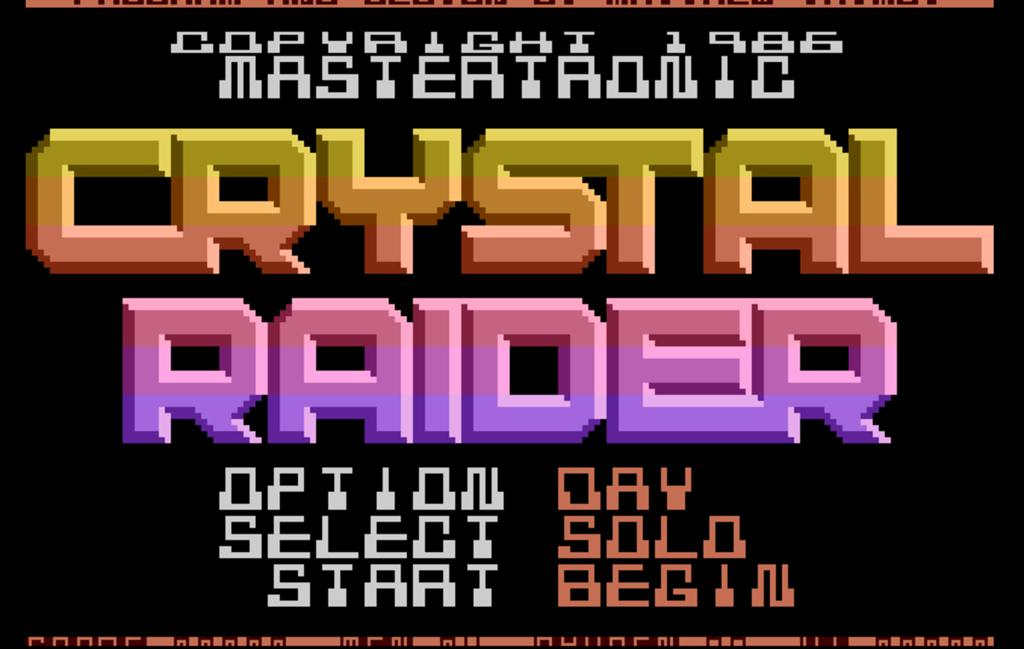<image>
Render a clear and concise summary of the photo. Video game screen that says "Crystal Raider" in colorful wording. 